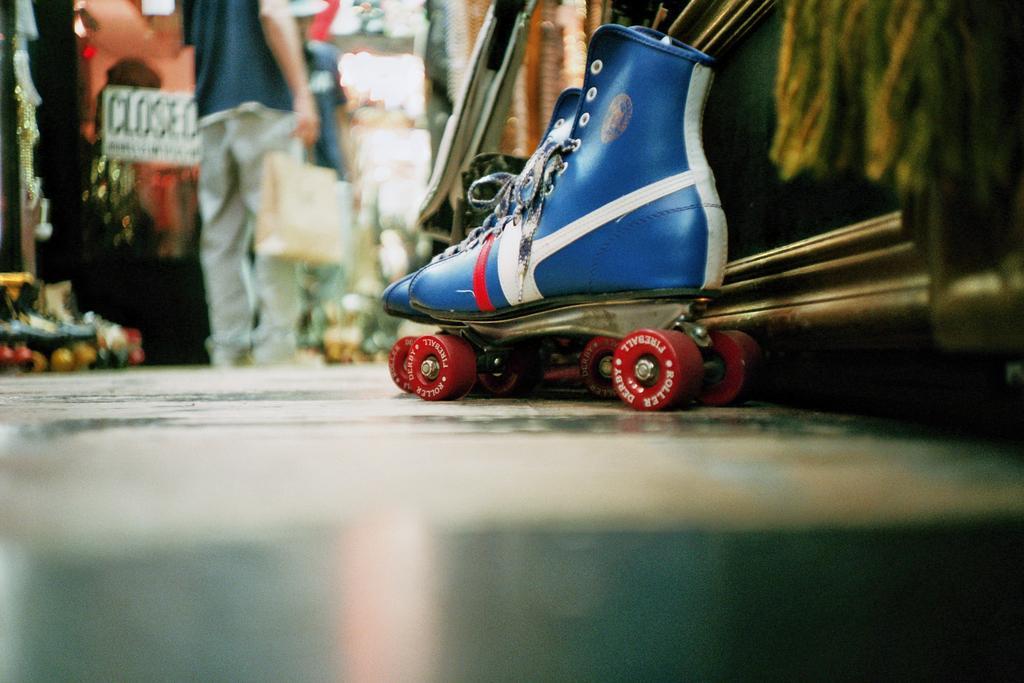Describe this image in one or two sentences. In this image in front there are quad skates on the floor. In the background of the image there are people standing on the floor. 